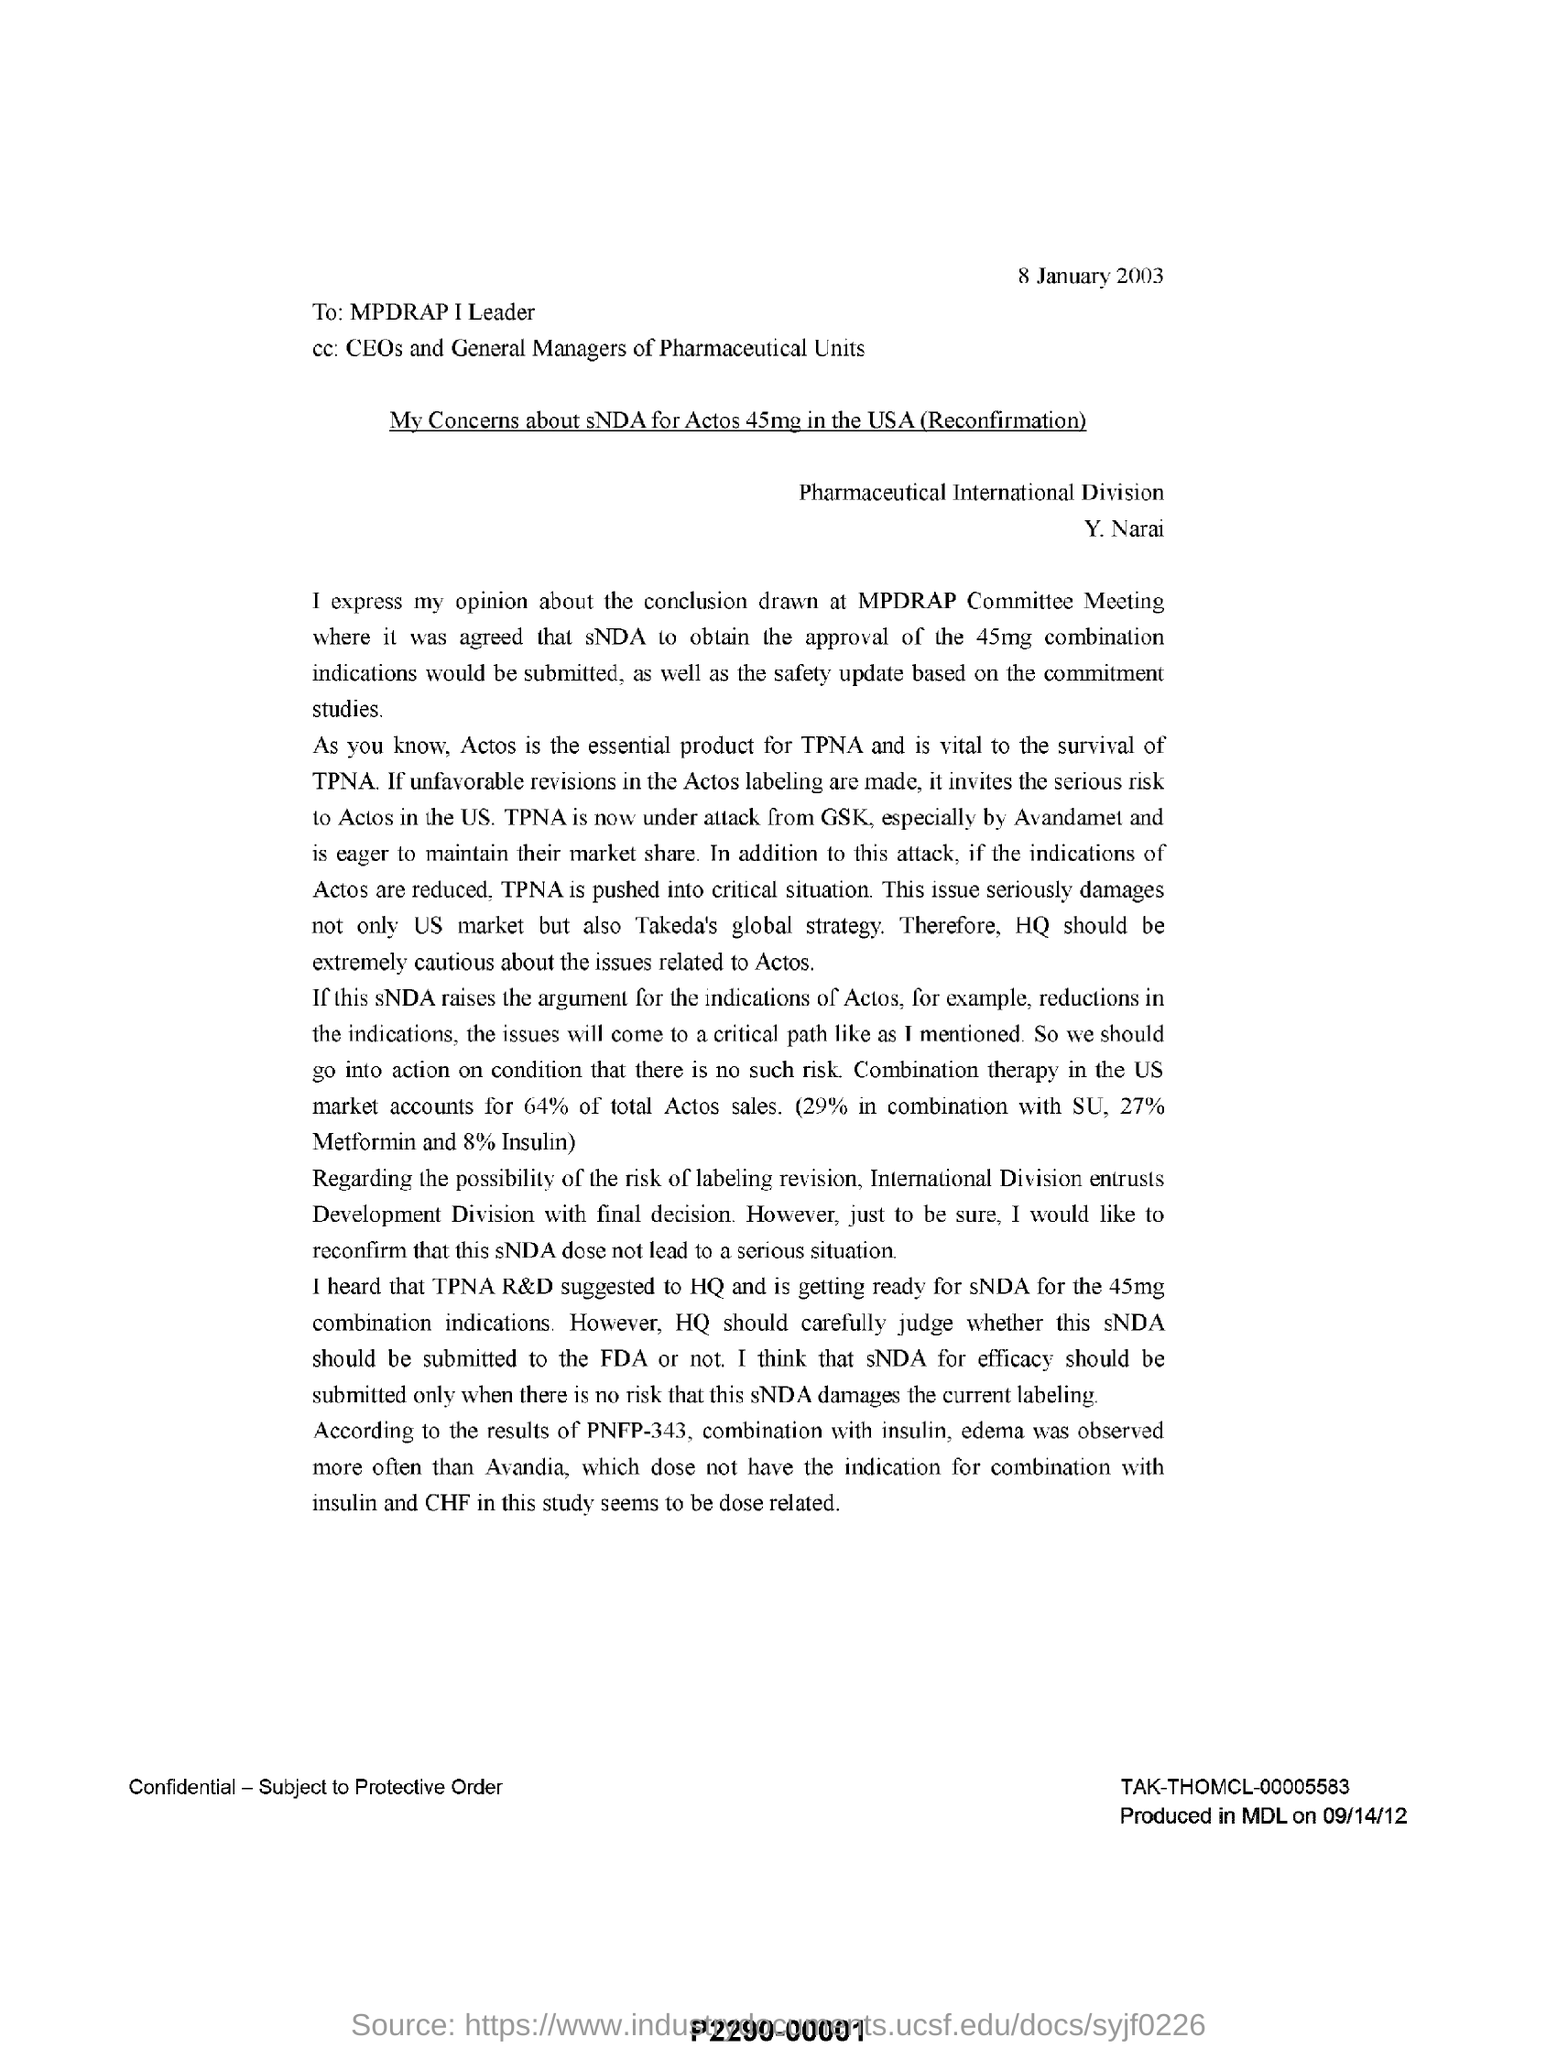Identify some key points in this picture. According to data, combination therapy in the US market accounts for approximately 64% of total Actos sales. This letter is addressed to the leader of MPDRAP I. The letter mentions that the date is 8 January 2003. The CC mentions CEOs and General Managers of Pharmaceutical Units as having the responsibility to take necessary measures to ensure that the employees are not subjected to aggravated work conditions or insufficient rest periods. 